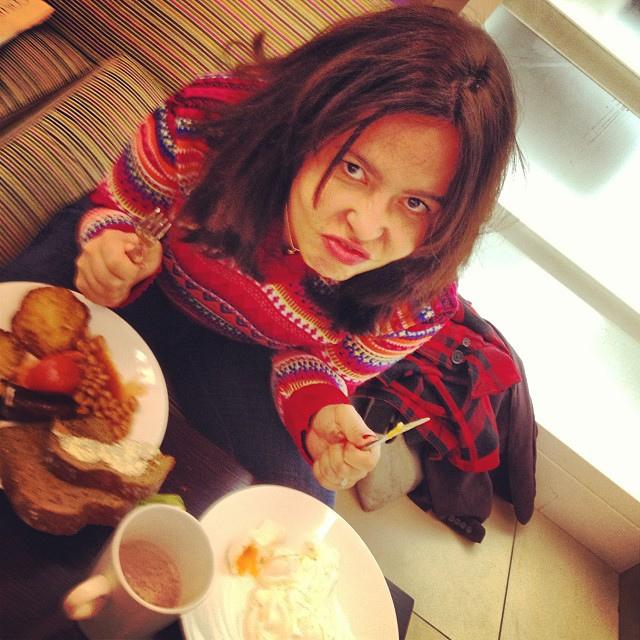Is the woman's hair brown?
Quick response, please. Yes. What is in the mug?
Keep it brief. Coffee. What style of breakfast is this?
Answer briefly. Continental. What is this person cutting?
Keep it brief. Food. 